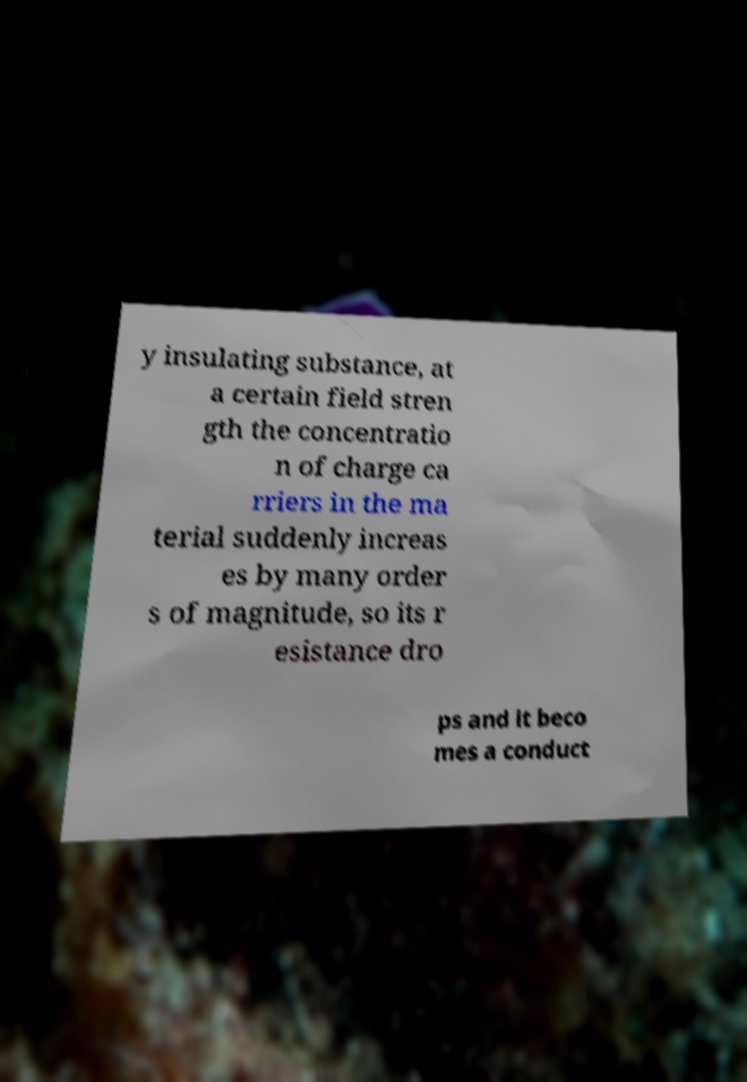I need the written content from this picture converted into text. Can you do that? y insulating substance, at a certain field stren gth the concentratio n of charge ca rriers in the ma terial suddenly increas es by many order s of magnitude, so its r esistance dro ps and it beco mes a conduct 